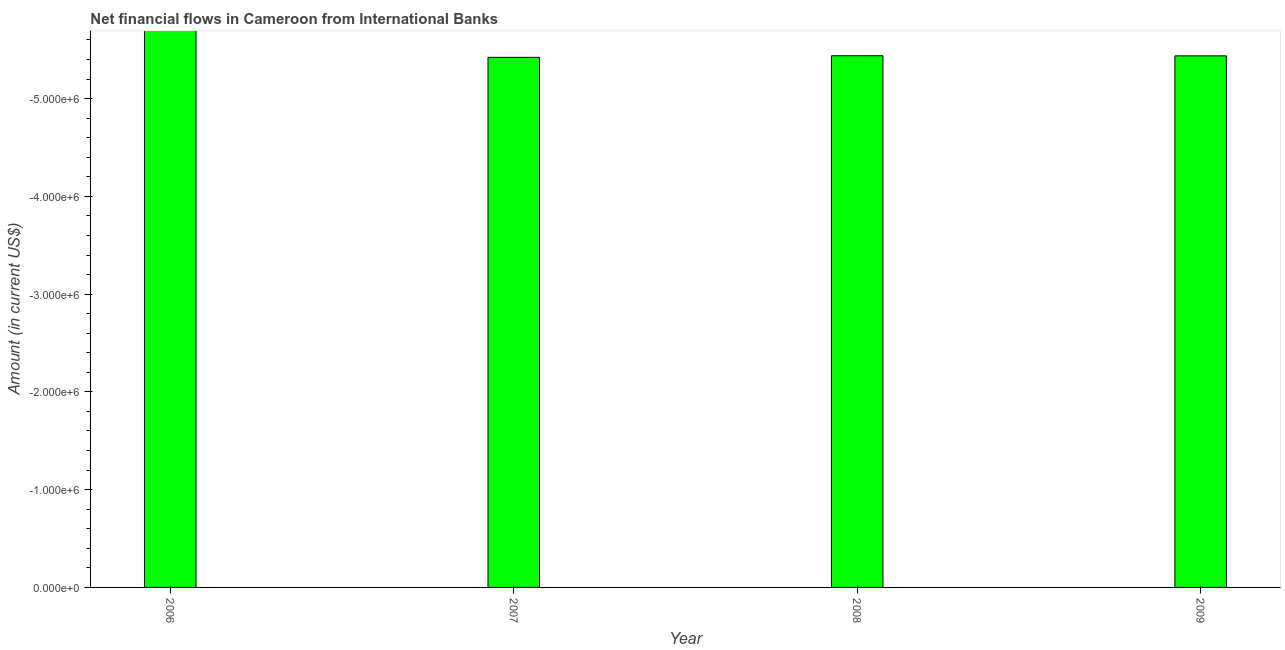What is the title of the graph?
Offer a very short reply. Net financial flows in Cameroon from International Banks. What is the label or title of the Y-axis?
Your response must be concise. Amount (in current US$). Across all years, what is the minimum net financial flows from ibrd?
Your answer should be very brief. 0. What is the sum of the net financial flows from ibrd?
Offer a terse response. 0. What is the median net financial flows from ibrd?
Offer a terse response. 0. In how many years, is the net financial flows from ibrd greater than the average net financial flows from ibrd taken over all years?
Give a very brief answer. 0. How many bars are there?
Your answer should be very brief. 0. Are all the bars in the graph horizontal?
Keep it short and to the point. No. What is the difference between two consecutive major ticks on the Y-axis?
Offer a very short reply. 1.00e+06. What is the Amount (in current US$) in 2006?
Provide a succinct answer. 0. 